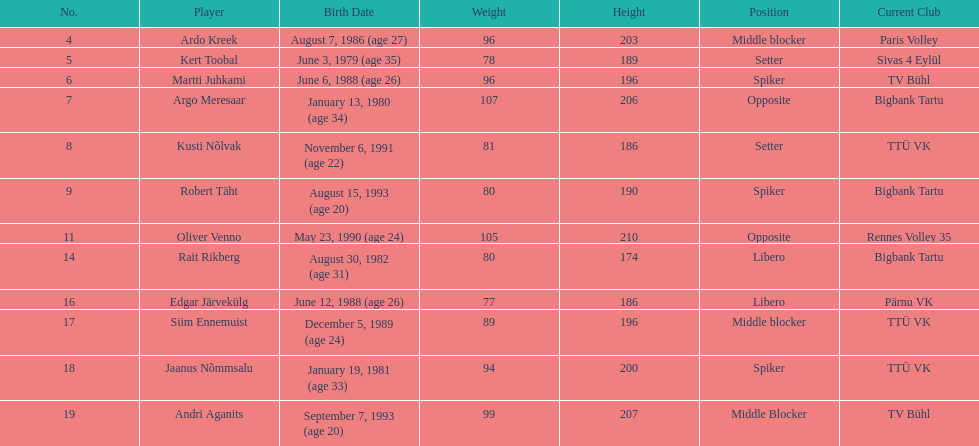Kert toobal is the oldest who is the next oldest player listed? Argo Meresaar. 